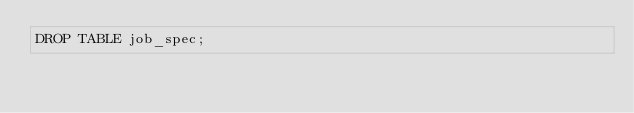<code> <loc_0><loc_0><loc_500><loc_500><_SQL_>DROP TABLE job_spec;
</code> 